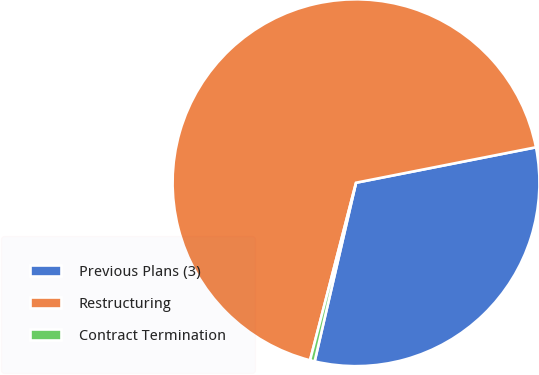Convert chart. <chart><loc_0><loc_0><loc_500><loc_500><pie_chart><fcel>Previous Plans (3)<fcel>Restructuring<fcel>Contract Termination<nl><fcel>31.72%<fcel>67.88%<fcel>0.41%<nl></chart> 